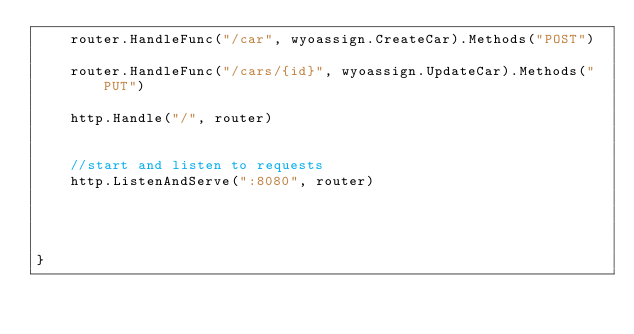<code> <loc_0><loc_0><loc_500><loc_500><_Go_>	router.HandleFunc("/car", wyoassign.CreateCar).Methods("POST")	
	router.HandleFunc("/cars/{id}", wyoassign.UpdateCar).Methods("PUT")

	http.Handle("/", router)
	

	//start and listen to requests
	http.ListenAndServe(":8080", router)
	



}</code> 